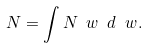<formula> <loc_0><loc_0><loc_500><loc_500>N = \int N _ { \ } w \ d \ w .</formula> 